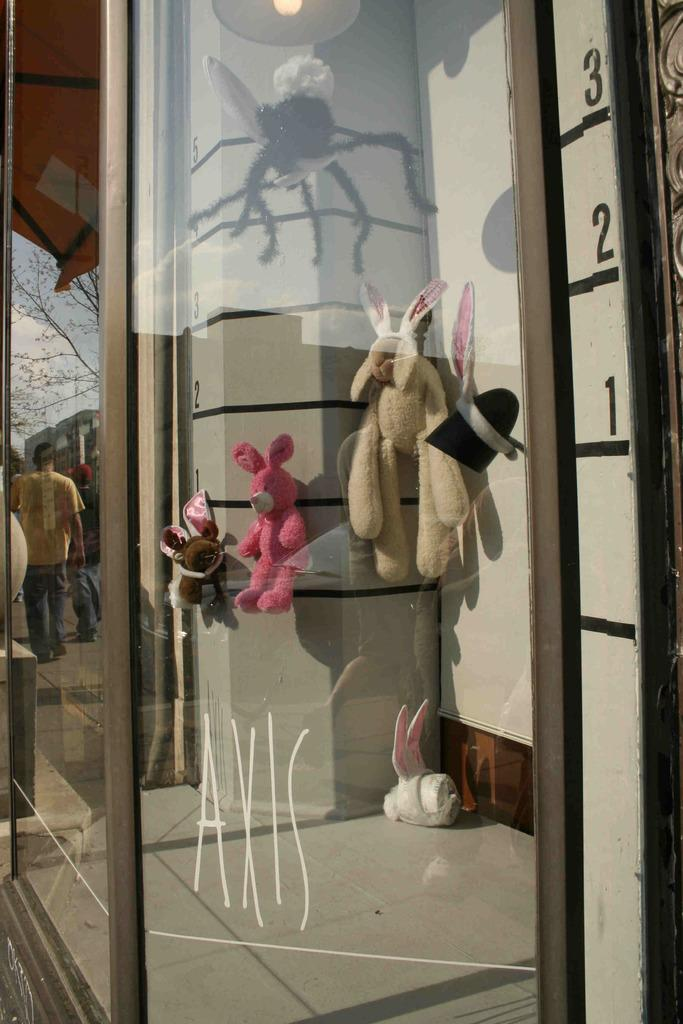What type of surface is present in the image? There is a glass surface in the image. What can be seen through the glass? Soft toys are visible through the glass. What is reflected on the glass surface? The reflection of trees, persons, buildings, and the sky is visible on the glass. How does the bulb affect the balance of the image? There is no bulb present in the image, so it cannot affect the balance. 